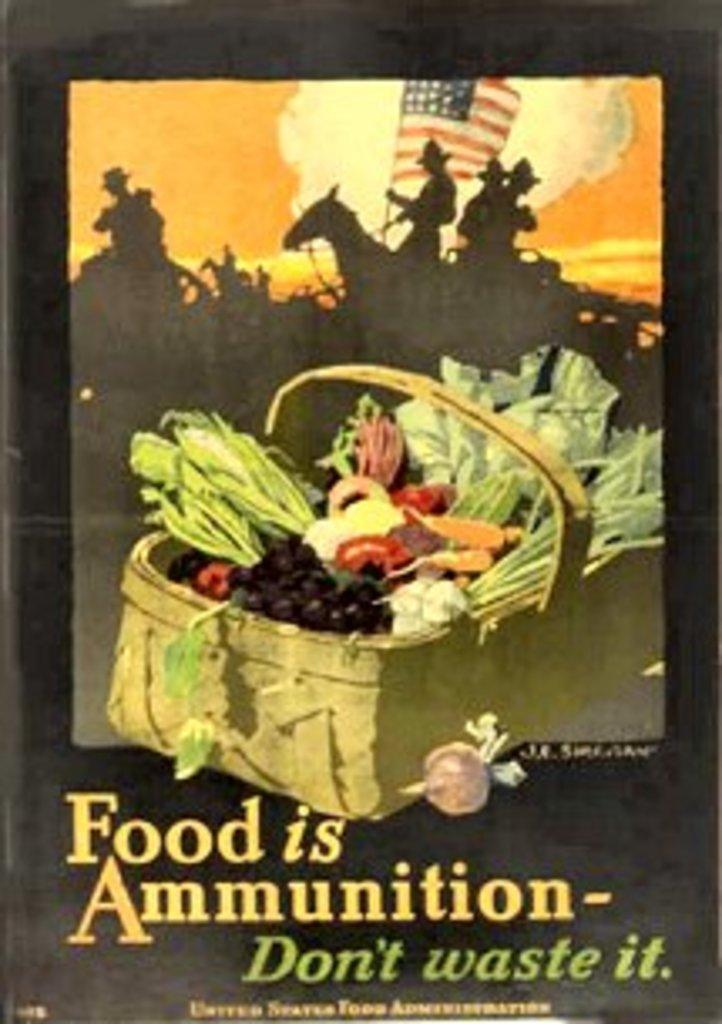<image>
Present a compact description of the photo's key features. A war poster picturing a peck basket full of vegetables and declaring that food is ammunition and should not be wasted. 